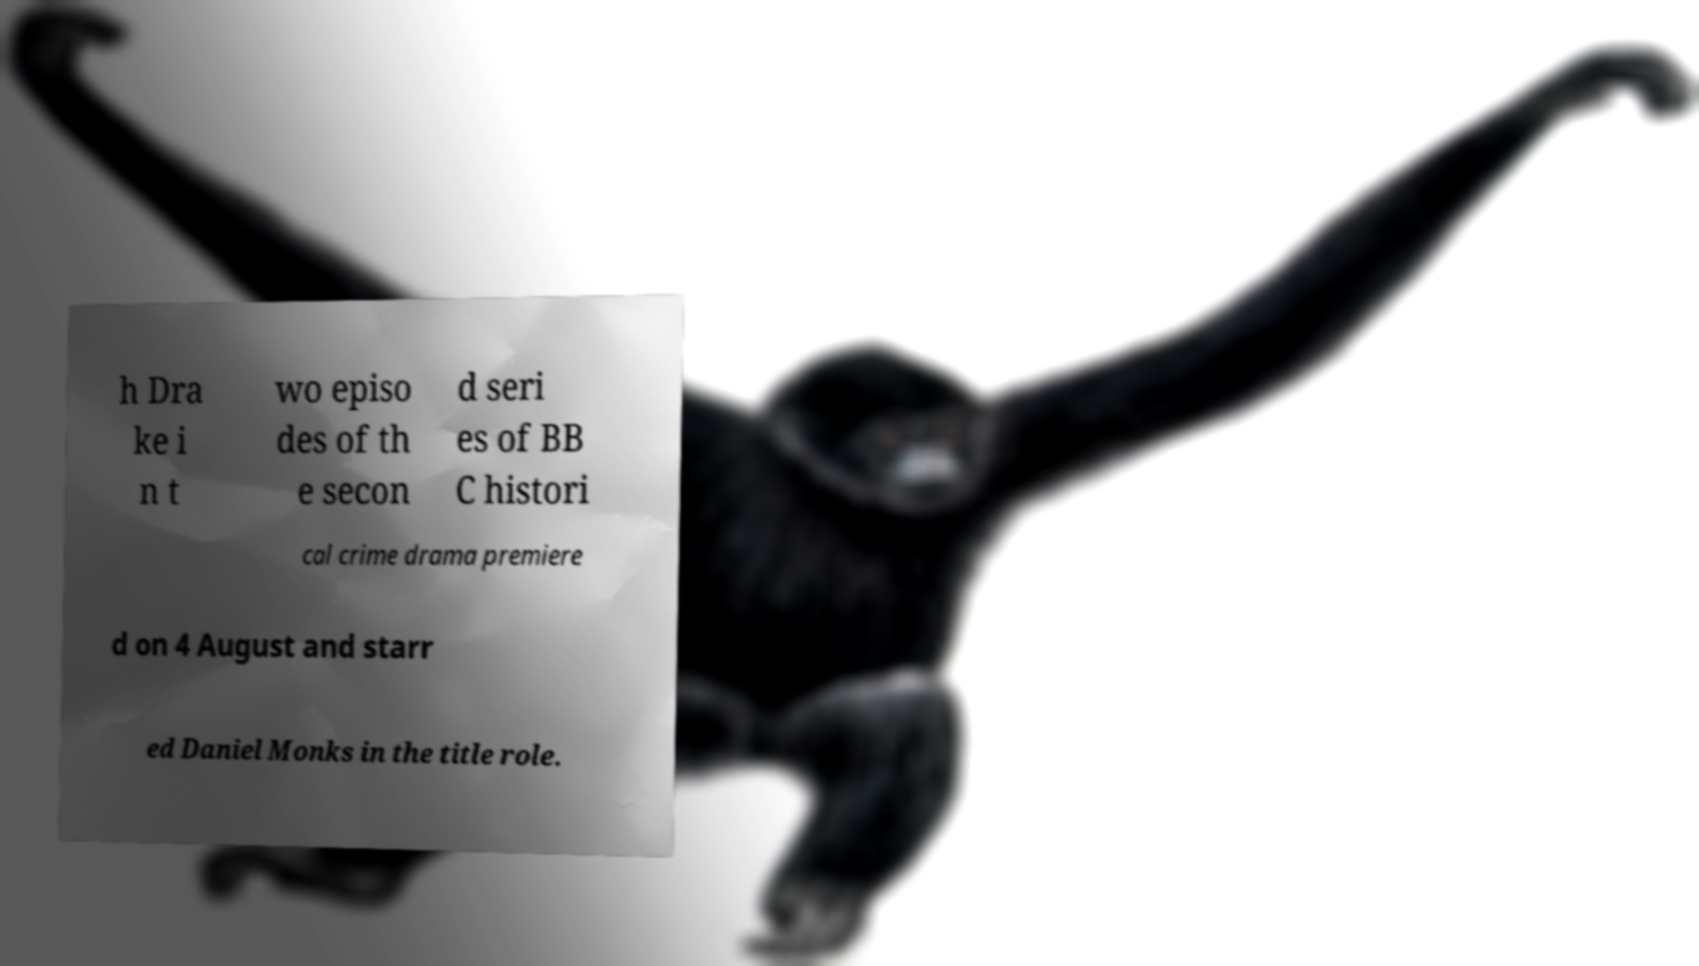Please identify and transcribe the text found in this image. h Dra ke i n t wo episo des of th e secon d seri es of BB C histori cal crime drama premiere d on 4 August and starr ed Daniel Monks in the title role. 